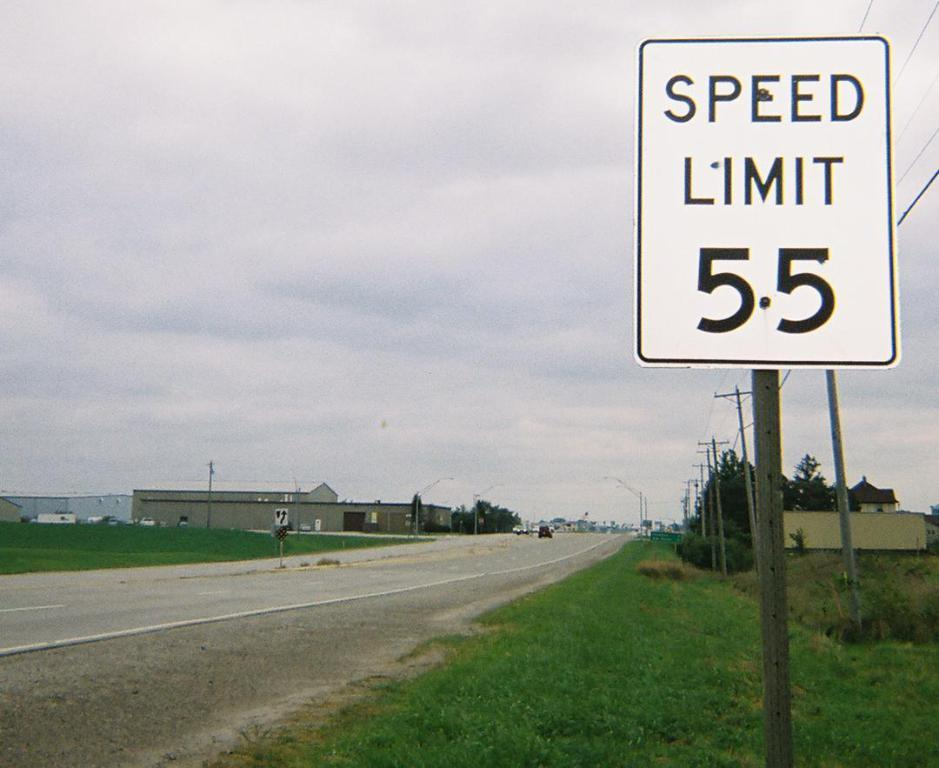Provide a one-sentence caption for the provided image. A speed limit sign indicates the limit is 55. 